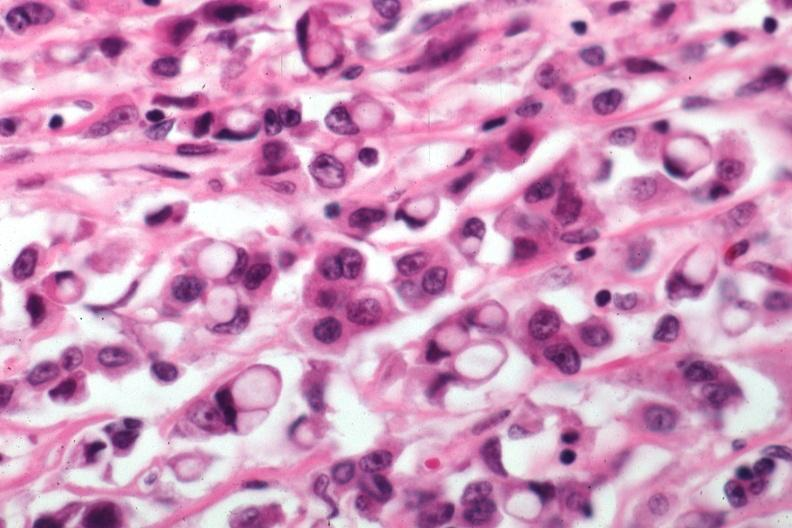how does this image show pleomorphic cells?
Answer the question using a single word or phrase. With obvious mucin secretion 